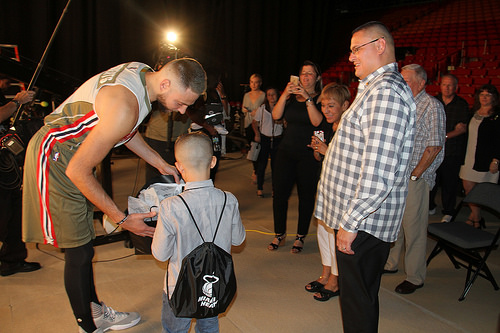<image>
Is there a woman behind the girl? Yes. From this viewpoint, the woman is positioned behind the girl, with the girl partially or fully occluding the woman. Is there a light above the child? No. The light is not positioned above the child. The vertical arrangement shows a different relationship. 